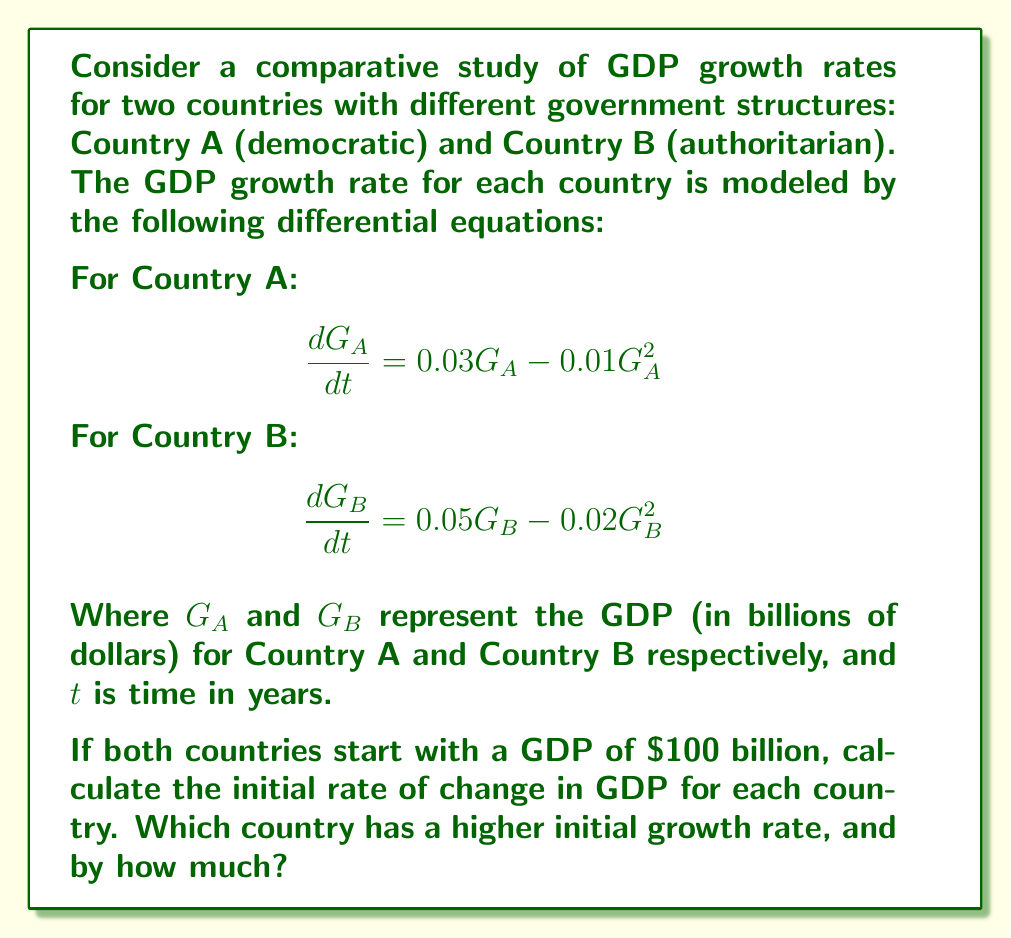Help me with this question. To solve this problem, we need to follow these steps:

1) For Country A:
   The initial GDP is $G_A = 100$ billion.
   Substitute this into the differential equation:
   $$\frac{dG_A}{dt} = 0.03G_A - 0.01G_A^2$$
   $$\frac{dG_A}{dt} = 0.03(100) - 0.01(100)^2$$
   $$\frac{dG_A}{dt} = 3 - 100 = -97$$ billion per year

2) For Country B:
   The initial GDP is $G_B = 100$ billion.
   Substitute this into the differential equation:
   $$\frac{dG_B}{dt} = 0.05G_B - 0.02G_B^2$$
   $$\frac{dG_B}{dt} = 0.05(100) - 0.02(100)^2$$
   $$\frac{dG_B}{dt} = 5 - 200 = -195$$ billion per year

3) Compare the initial growth rates:
   Country A: -97 billion/year
   Country B: -195 billion/year

   The difference in growth rates:
   $|-195| - |-97| = 195 - 97 = 98$ billion/year

   Country B has a higher initial rate of change in absolute terms, but both are negative, indicating initial economic contraction.
Answer: Country B has a higher initial rate of change by $98 billion per year, but both countries show initial economic contraction. 